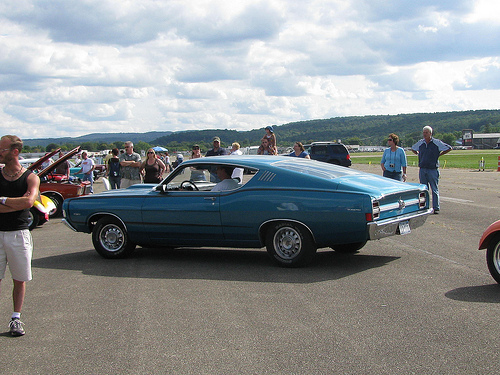<image>
Is there a man on the car? No. The man is not positioned on the car. They may be near each other, but the man is not supported by or resting on top of the car. Is the red car next to the black shirt? No. The red car is not positioned next to the black shirt. They are located in different areas of the scene. Where is the car in relation to the man? Is it in front of the man? No. The car is not in front of the man. The spatial positioning shows a different relationship between these objects. Where is the car in relation to the ground? Is it above the ground? No. The car is not positioned above the ground. The vertical arrangement shows a different relationship. 